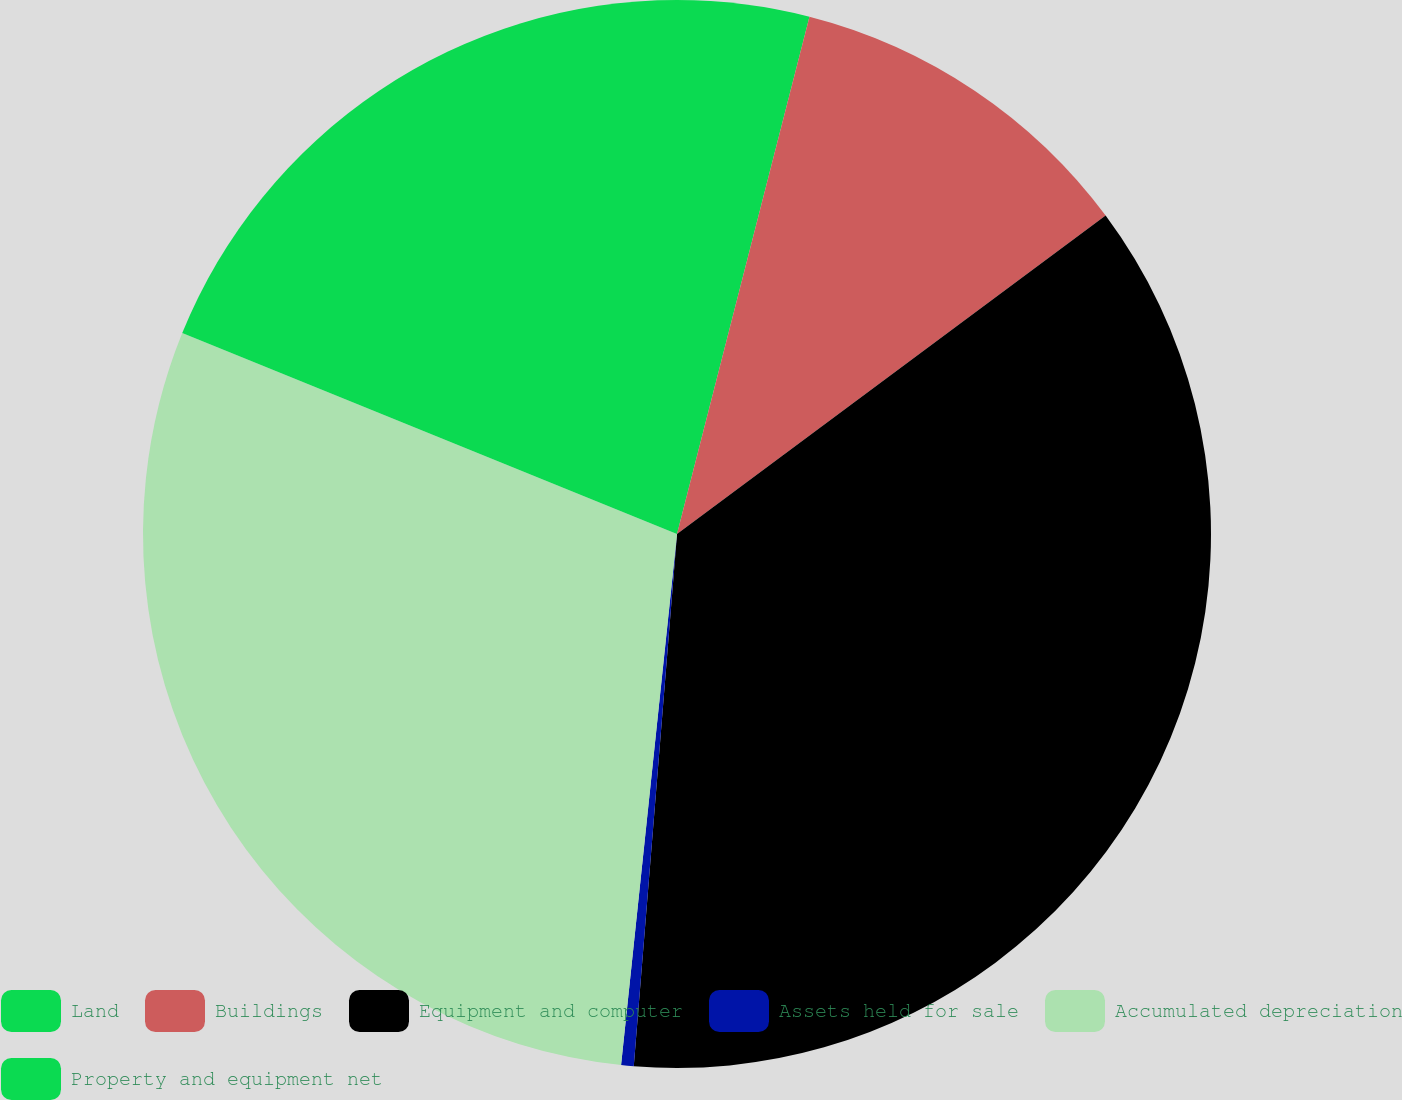Convert chart to OTSL. <chart><loc_0><loc_0><loc_500><loc_500><pie_chart><fcel>Land<fcel>Buildings<fcel>Equipment and computer<fcel>Assets held for sale<fcel>Accumulated depreciation<fcel>Property and equipment net<nl><fcel>3.99%<fcel>10.84%<fcel>36.46%<fcel>0.38%<fcel>29.47%<fcel>18.86%<nl></chart> 